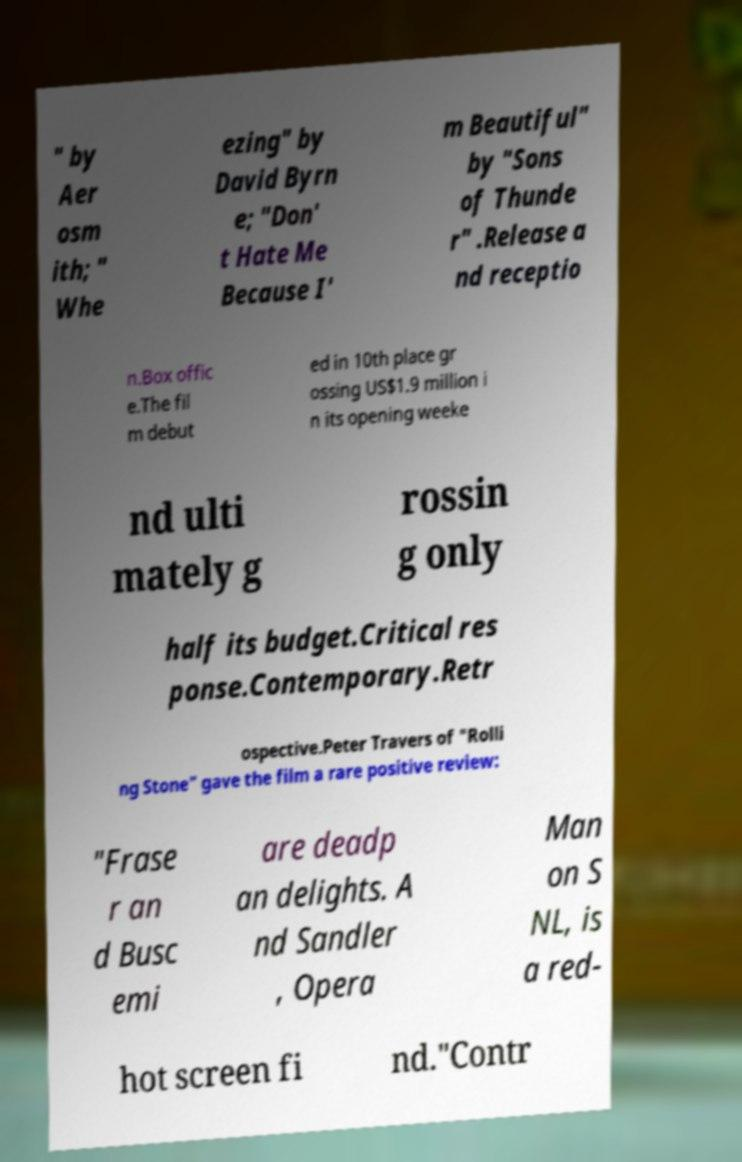Could you assist in decoding the text presented in this image and type it out clearly? " by Aer osm ith; " Whe ezing" by David Byrn e; "Don' t Hate Me Because I' m Beautiful" by "Sons of Thunde r" .Release a nd receptio n.Box offic e.The fil m debut ed in 10th place gr ossing US$1.9 million i n its opening weeke nd ulti mately g rossin g only half its budget.Critical res ponse.Contemporary.Retr ospective.Peter Travers of "Rolli ng Stone" gave the film a rare positive review: "Frase r an d Busc emi are deadp an delights. A nd Sandler , Opera Man on S NL, is a red- hot screen fi nd."Contr 